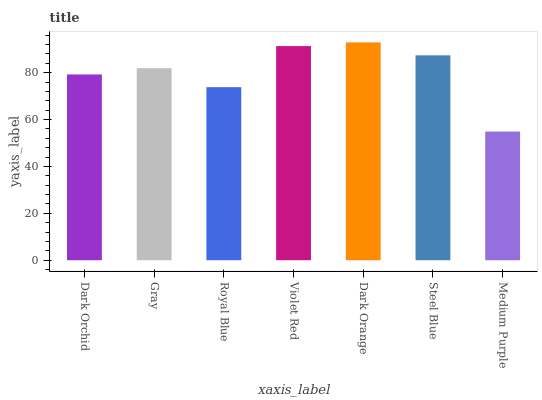Is Dark Orange the maximum?
Answer yes or no. Yes. Is Gray the minimum?
Answer yes or no. No. Is Gray the maximum?
Answer yes or no. No. Is Gray greater than Dark Orchid?
Answer yes or no. Yes. Is Dark Orchid less than Gray?
Answer yes or no. Yes. Is Dark Orchid greater than Gray?
Answer yes or no. No. Is Gray less than Dark Orchid?
Answer yes or no. No. Is Gray the high median?
Answer yes or no. Yes. Is Gray the low median?
Answer yes or no. Yes. Is Dark Orchid the high median?
Answer yes or no. No. Is Medium Purple the low median?
Answer yes or no. No. 